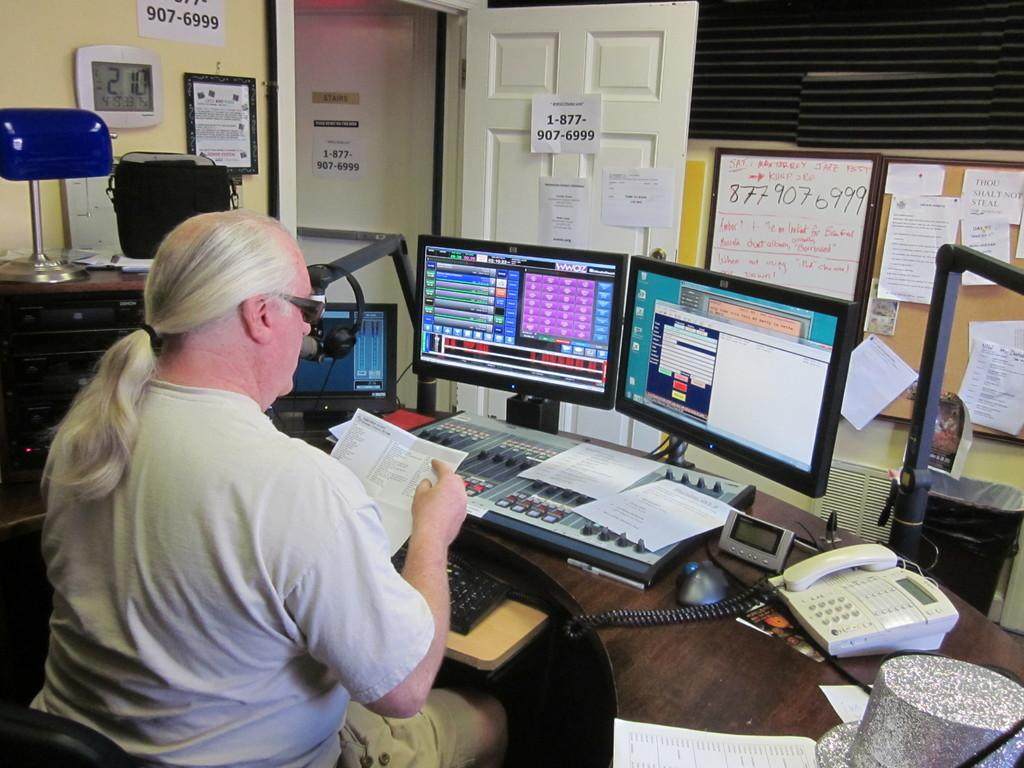<image>
Write a terse but informative summary of the picture. A paper posted on the door has the phone number 1-877-907-6999 on it. 